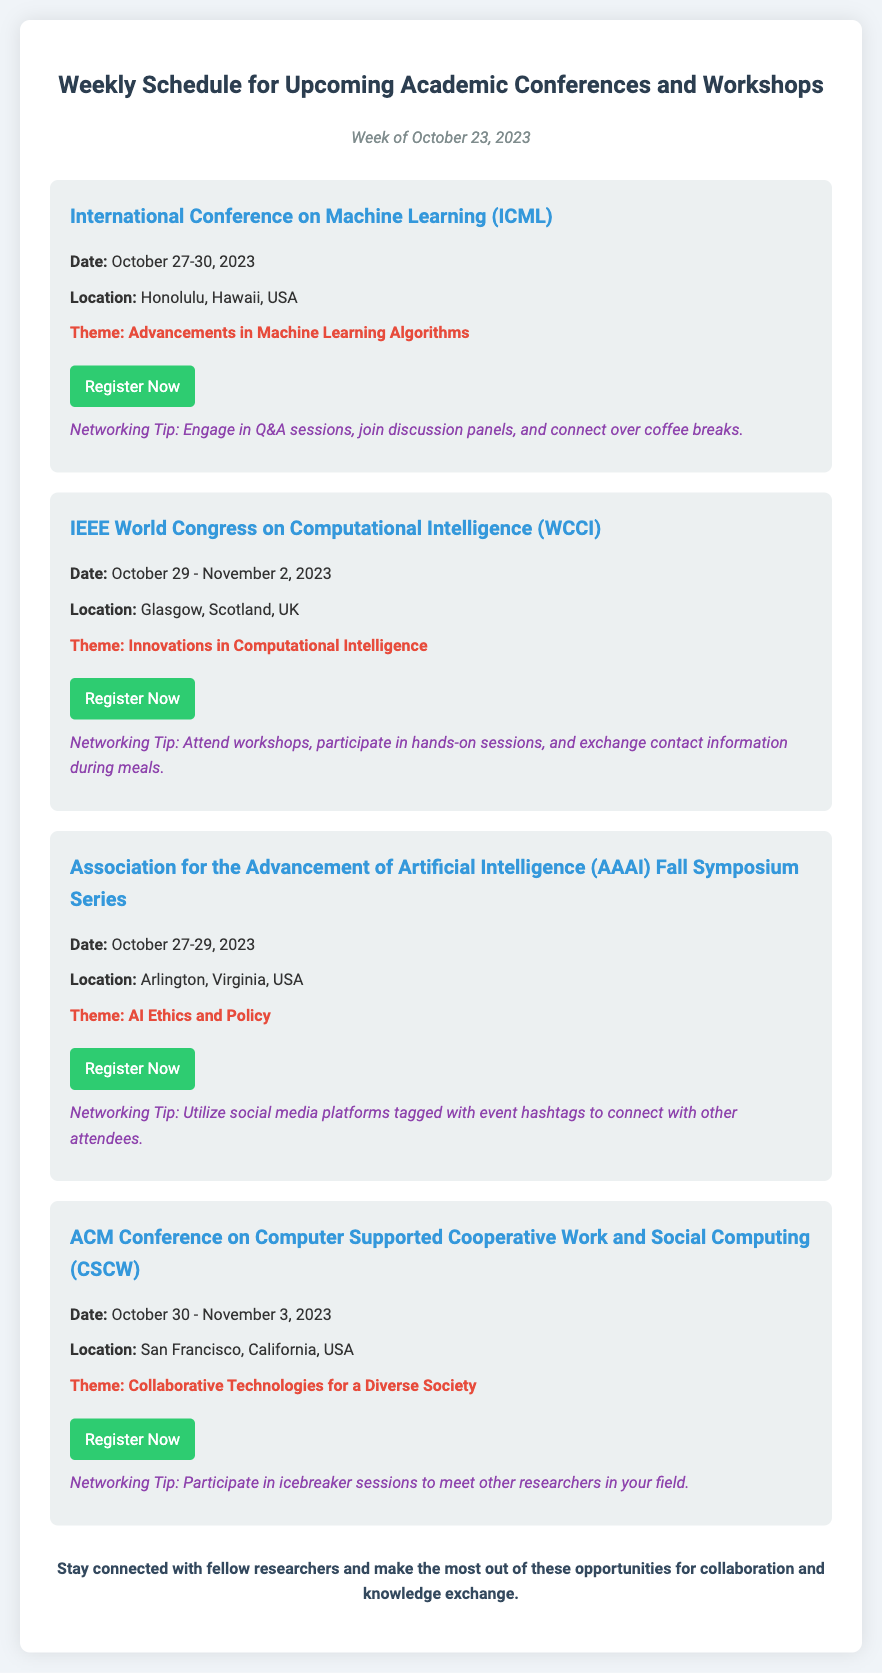what is the date of the International Conference on Machine Learning? The date is mentioned as October 27-30, 2023.
Answer: October 27-30, 2023 where is the IEEE World Congress on Computational Intelligence taking place? The location is specified as Glasgow, Scotland, UK.
Answer: Glasgow, Scotland, UK what is the theme of the Association for the Advancement of Artificial Intelligence Fall Symposium Series? The theme is stated as AI Ethics and Policy.
Answer: AI Ethics and Policy how many days does the ACM Conference on Computer Supported Cooperative Work and Social Computing last? The duration is calculated by subtracting the starting date from the ending date, which is October 30 - November 3, 2023 (5 days).
Answer: 5 days what is one networking tip provided for the ACML Conference? The document includes networking tips; one tip is to engage in Q&A sessions, join discussion panels, and connect over coffee breaks.
Answer: Engage in Q&A sessions what is the earliest start date of the conferences listed? The earliest date is provided for the International Conference on Machine Learning, which starts on October 27, 2023.
Answer: October 27, 2023 what type of event is the document primarily focused on? The document outlines various academic conferences and workshops, emphasizing scholarly activities.
Answer: Academic conferences and workshops 